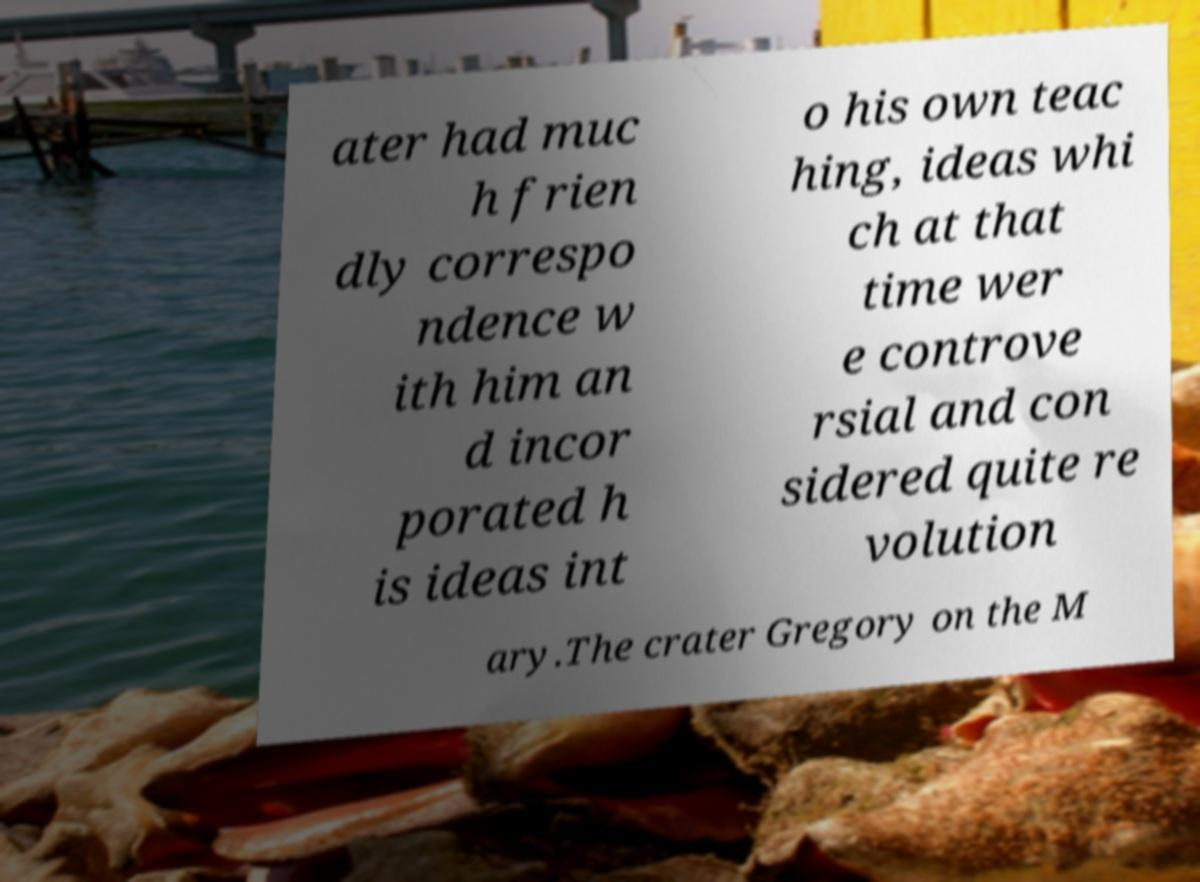Please identify and transcribe the text found in this image. ater had muc h frien dly correspo ndence w ith him an d incor porated h is ideas int o his own teac hing, ideas whi ch at that time wer e controve rsial and con sidered quite re volution ary.The crater Gregory on the M 